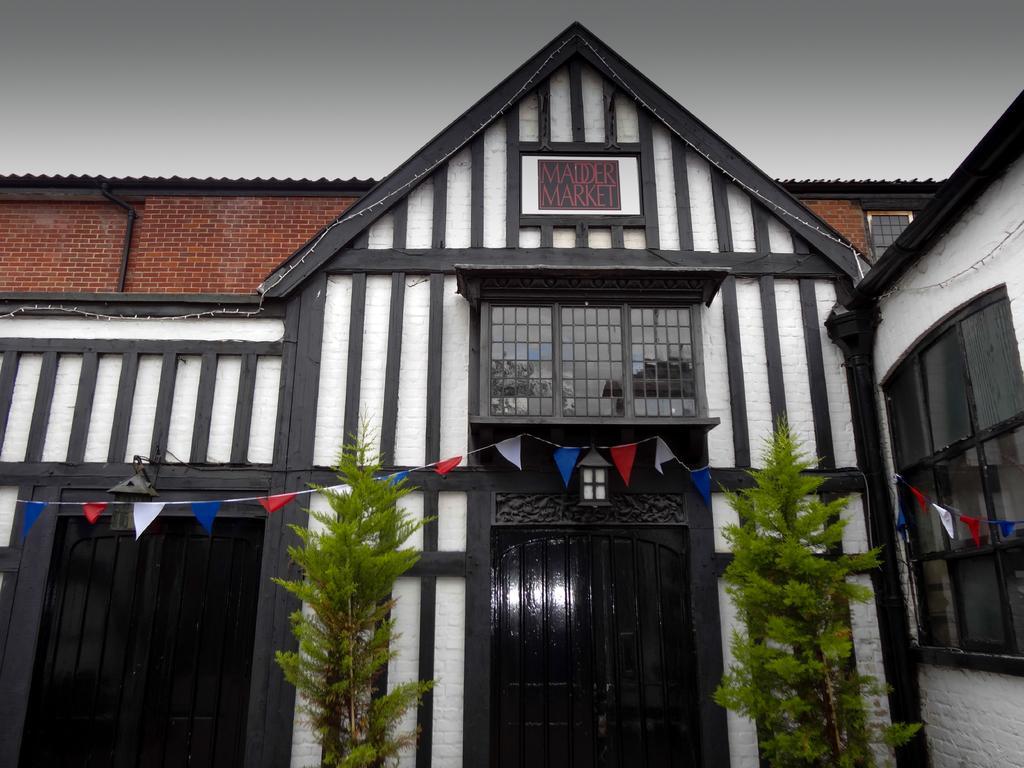How would you summarize this image in a sentence or two? In this image we can see a building, glass windows and doors. In-front of this building there are flags and plants.   